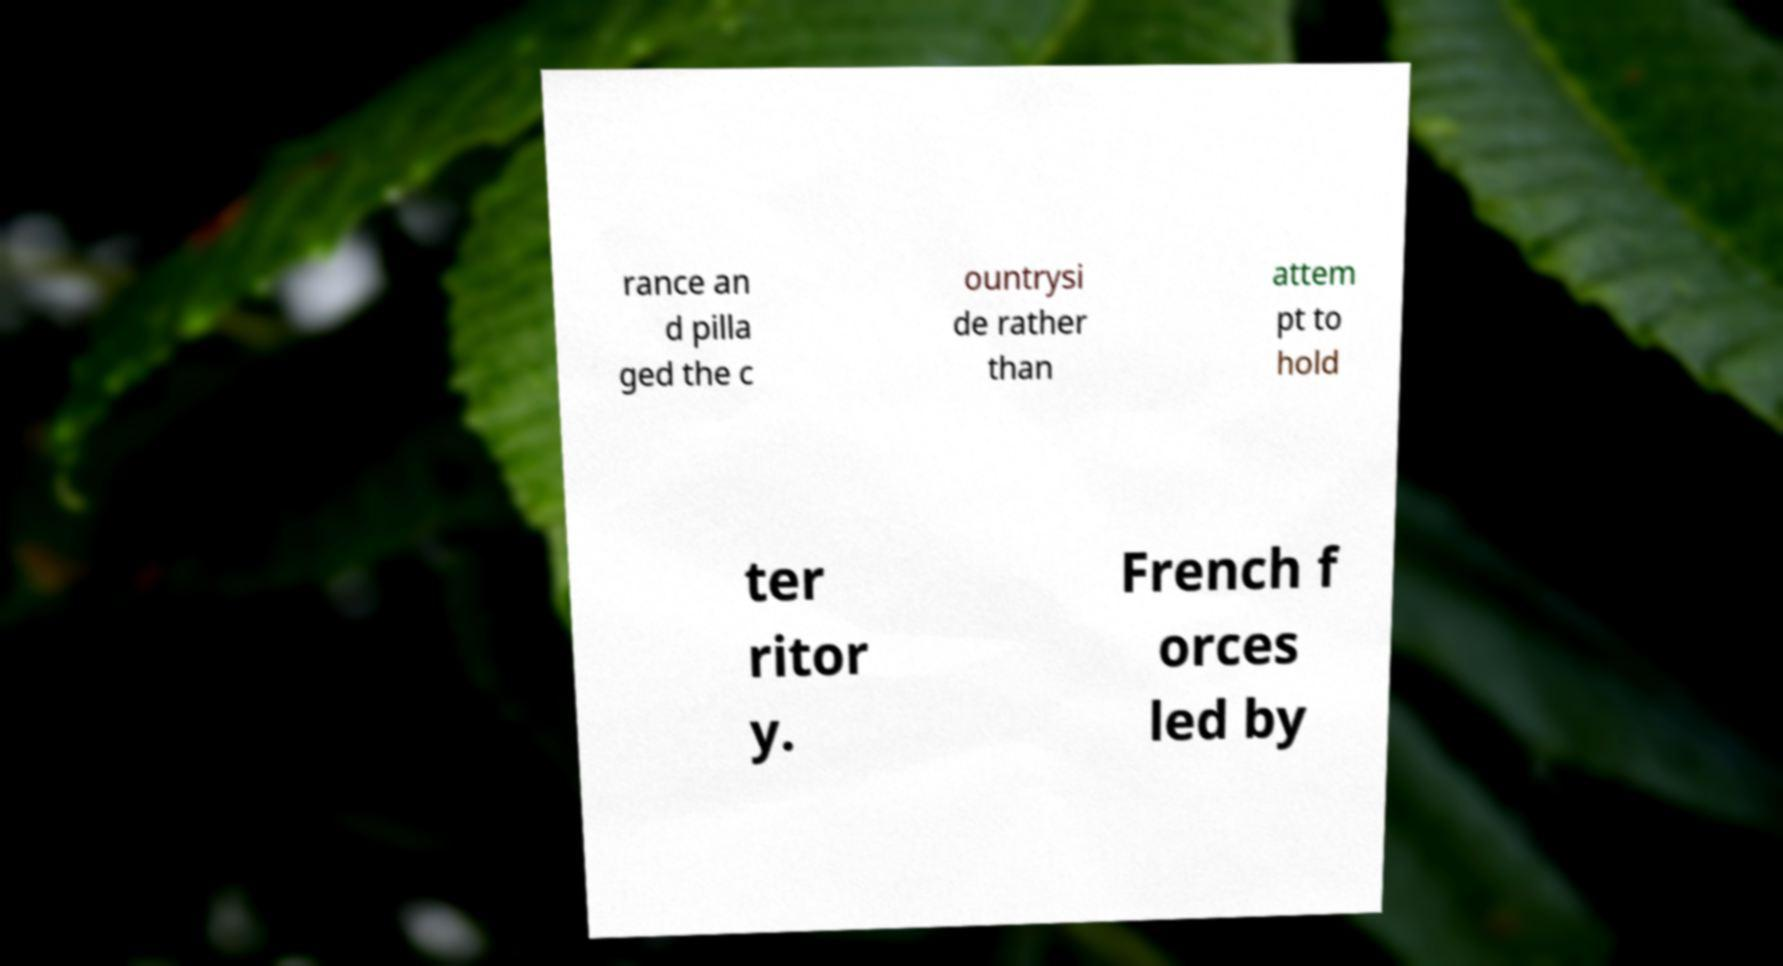Please read and relay the text visible in this image. What does it say? rance an d pilla ged the c ountrysi de rather than attem pt to hold ter ritor y. French f orces led by 